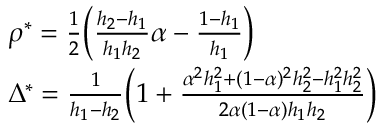<formula> <loc_0><loc_0><loc_500><loc_500>\begin{array} { r l } & { \rho ^ { * } = \frac { 1 } { 2 } \left ( \frac { h _ { 2 } - h _ { 1 } } { h _ { 1 } h _ { 2 } } \alpha - \frac { 1 - h _ { 1 } } { h _ { 1 } } \right ) } \\ & { \Delta ^ { * } = \frac { 1 } { h _ { 1 } - h _ { 2 } } \left ( 1 + \frac { \alpha ^ { 2 } h _ { 1 } ^ { 2 } + ( 1 - \alpha ) ^ { 2 } h _ { 2 } ^ { 2 } - h _ { 1 } ^ { 2 } h _ { 2 } ^ { 2 } } { 2 \alpha ( 1 - \alpha ) h _ { 1 } h _ { 2 } } \right ) } \end{array}</formula> 